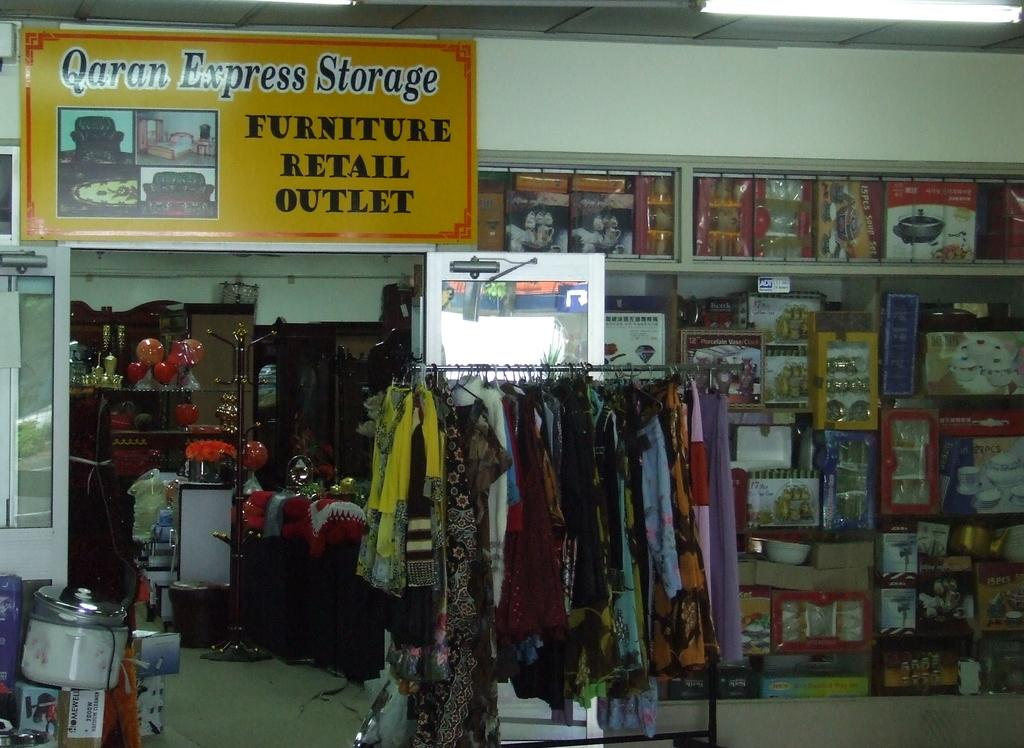Provide a one-sentence caption for the provided image. a furniture retail outlet store interior has a sign reading Qaran Express Storage. 